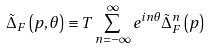Convert formula to latex. <formula><loc_0><loc_0><loc_500><loc_500>\tilde { \Delta } _ { F } \left ( p , \theta \right ) \equiv T \sum _ { n = - \infty } ^ { \infty } e ^ { i n \theta } \tilde { \Delta } _ { F } ^ { n } \left ( p \right )</formula> 